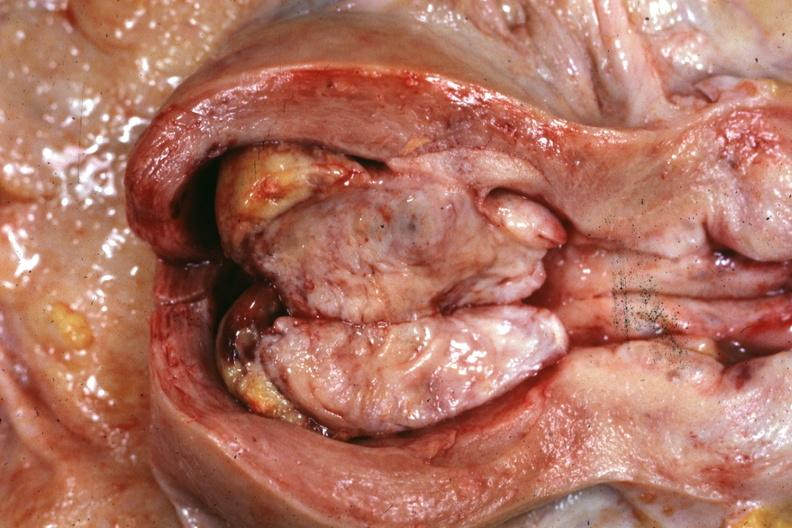where does this part belong to?
Answer the question using a single word or phrase. Female reproductive system 